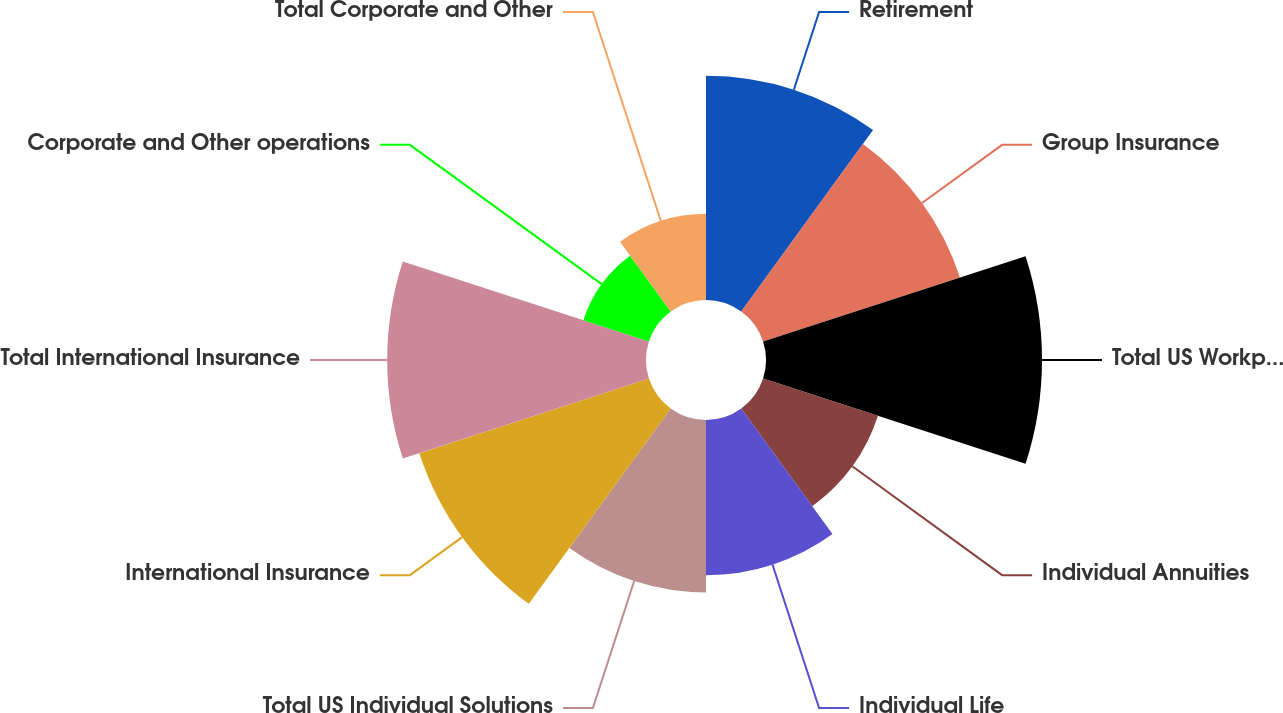<chart> <loc_0><loc_0><loc_500><loc_500><pie_chart><fcel>Retirement<fcel>Group Insurance<fcel>Total US Workplace Solutions<fcel>Individual Annuities<fcel>Individual Life<fcel>Total US Individual Solutions<fcel>International Insurance<fcel>Total International Insurance<fcel>Corporate and Other operations<fcel>Total Corporate and Other<nl><fcel>12.38%<fcel>11.43%<fcel>15.24%<fcel>6.67%<fcel>8.57%<fcel>9.52%<fcel>13.33%<fcel>14.29%<fcel>3.81%<fcel>4.76%<nl></chart> 